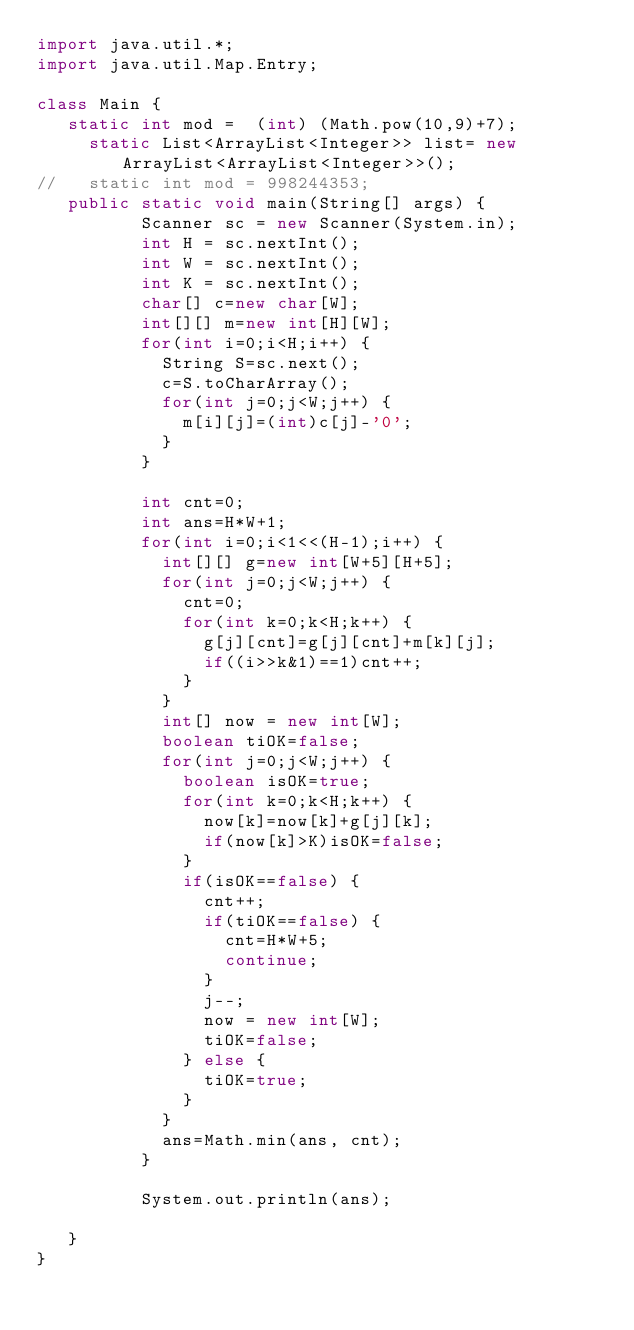Convert code to text. <code><loc_0><loc_0><loc_500><loc_500><_Java_>import java.util.*;
import java.util.Map.Entry;
 
class Main {
	 static int mod =  (int) (Math.pow(10,9)+7);
   	 static List<ArrayList<Integer>> list= new ArrayList<ArrayList<Integer>>();
//	 static int mod = 998244353;
	 public static void main(String[] args) {
	        Scanner sc = new Scanner(System.in);
	        int H = sc.nextInt();
	        int W = sc.nextInt();
	        int K = sc.nextInt();
	        char[] c=new char[W];
	        int[][] m=new int[H][W];
	        for(int i=0;i<H;i++) {
	        	String S=sc.next();
	        	c=S.toCharArray();
	        	for(int j=0;j<W;j++) {
	        		m[i][j]=(int)c[j]-'0';
	        	}
	        }
	        
	        int cnt=0;
	        int ans=H*W+1;
	        for(int i=0;i<1<<(H-1);i++) {
		        int[][] g=new int[W+5][H+5];
	        	for(int j=0;j<W;j++) {
			        cnt=0;
	        		for(int k=0;k<H;k++) {
	        			g[j][cnt]=g[j][cnt]+m[k][j];
	        			if((i>>k&1)==1)cnt++;
	        		}
	        	}
	        	int[] now = new int[W];
        		boolean tiOK=false;
	        	for(int j=0;j<W;j++) {
	        		boolean isOK=true;
	        		for(int k=0;k<H;k++) {
	        			now[k]=now[k]+g[j][k];
	        			if(now[k]>K)isOK=false;
	        		}
	        		if(isOK==false) {
	        			cnt++;
	        			if(tiOK==false) {
	        				cnt=H*W+5;
	        				continue;
	        			}
	        			j--;
	        			now = new int[W];
	        			tiOK=false;
	        		} else {
	        			tiOK=true;
	        		}
	        	}
	        	ans=Math.min(ans, cnt);
	        }
	        
	        System.out.println(ans);
	        	        	        
	 }
}</code> 